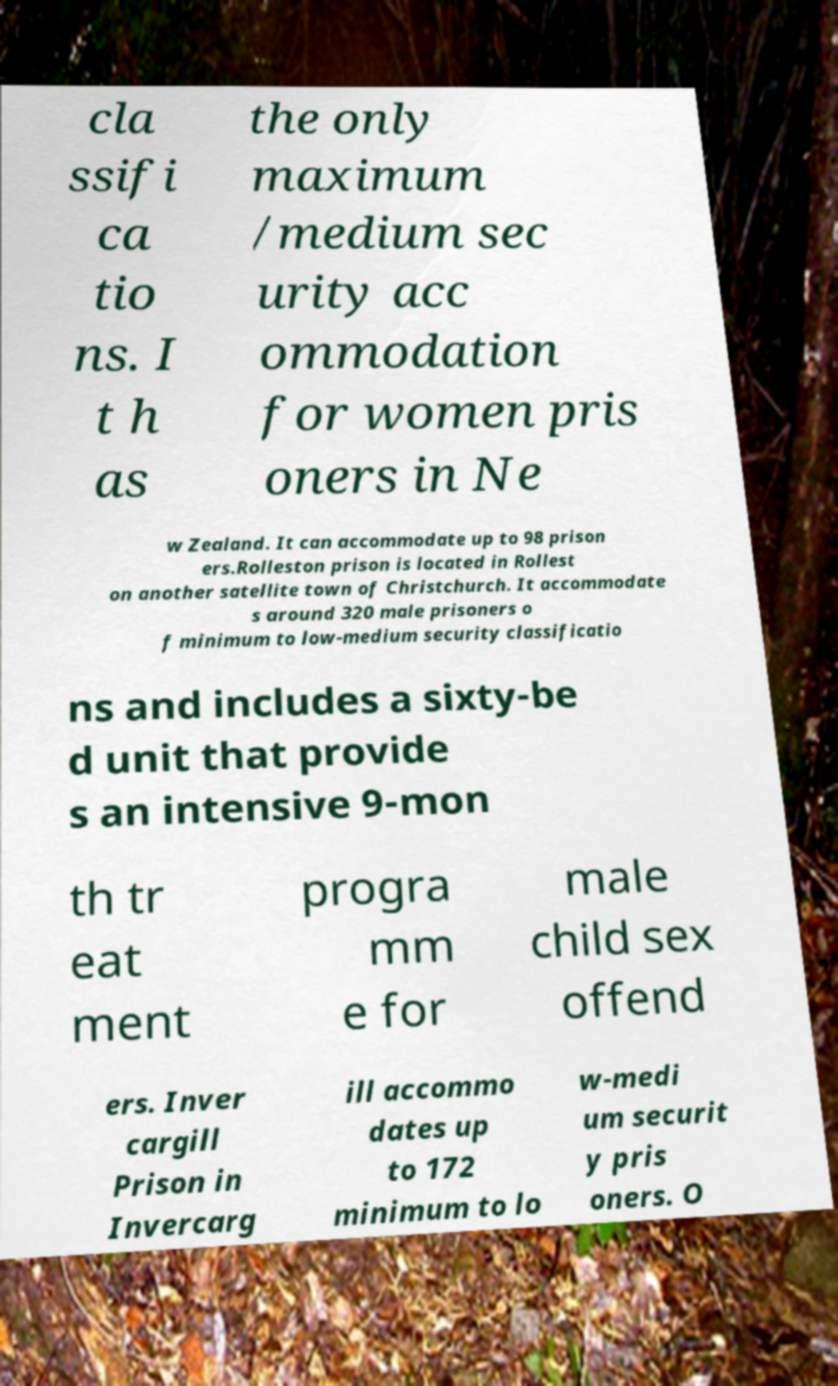Could you extract and type out the text from this image? cla ssifi ca tio ns. I t h as the only maximum /medium sec urity acc ommodation for women pris oners in Ne w Zealand. It can accommodate up to 98 prison ers.Rolleston prison is located in Rollest on another satellite town of Christchurch. It accommodate s around 320 male prisoners o f minimum to low-medium security classificatio ns and includes a sixty-be d unit that provide s an intensive 9-mon th tr eat ment progra mm e for male child sex offend ers. Inver cargill Prison in Invercarg ill accommo dates up to 172 minimum to lo w-medi um securit y pris oners. O 